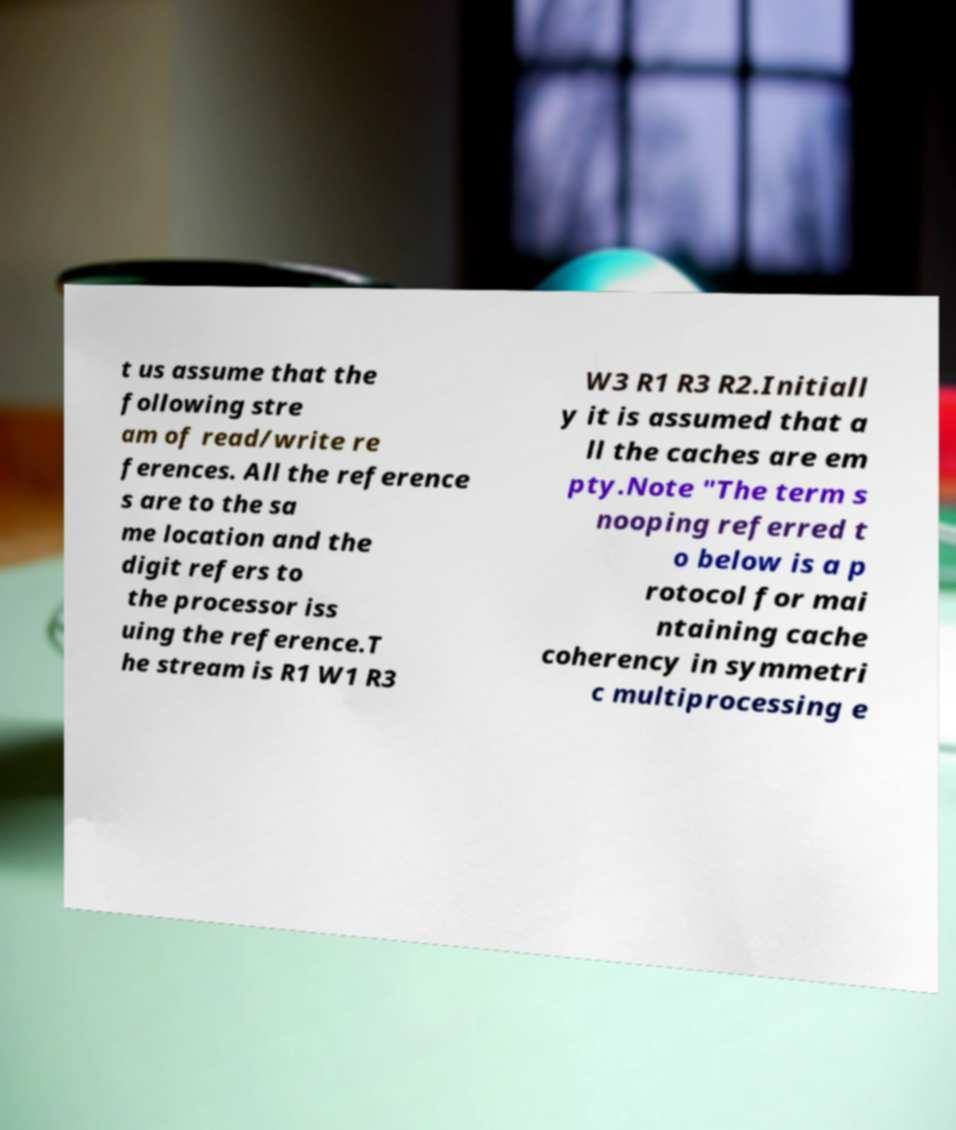For documentation purposes, I need the text within this image transcribed. Could you provide that? t us assume that the following stre am of read/write re ferences. All the reference s are to the sa me location and the digit refers to the processor iss uing the reference.T he stream is R1 W1 R3 W3 R1 R3 R2.Initiall y it is assumed that a ll the caches are em pty.Note "The term s nooping referred t o below is a p rotocol for mai ntaining cache coherency in symmetri c multiprocessing e 